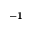<formula> <loc_0><loc_0><loc_500><loc_500>^ { - 1 }</formula> 